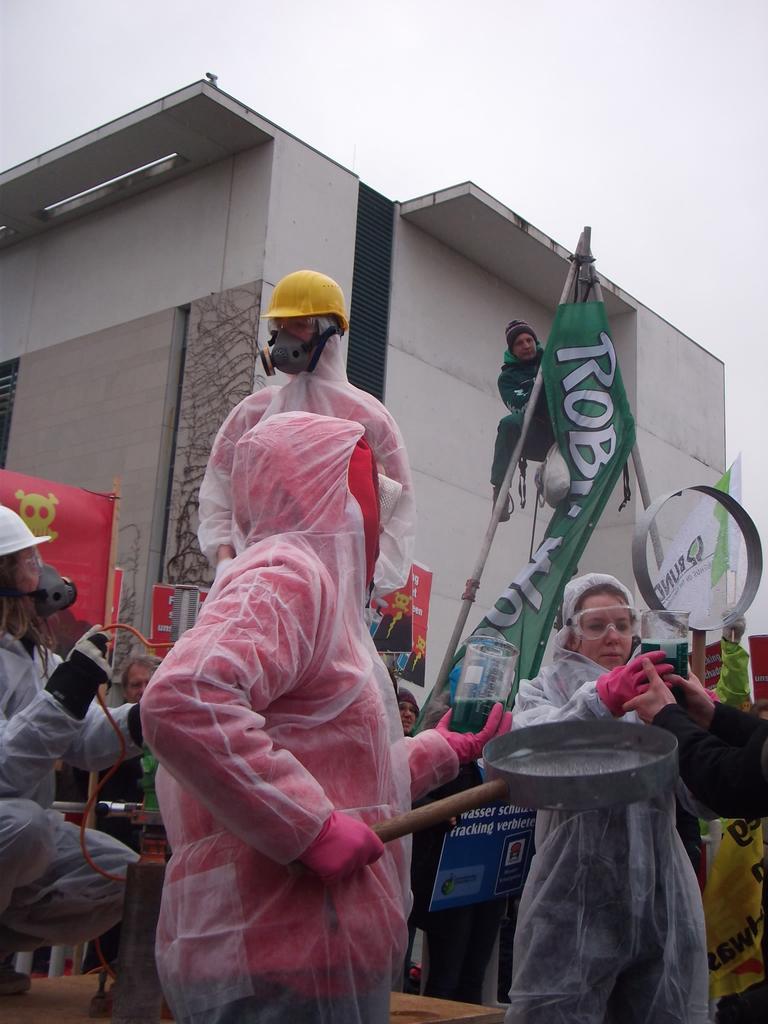Could you give a brief overview of what you see in this image? In this image I can see few persons wearing plastic covers are standing and holding few objects in their hands. In the background I can see a building, few red colored banners, a green colored banner, few poles, a person on the pole, a white colored flag and the sky. 